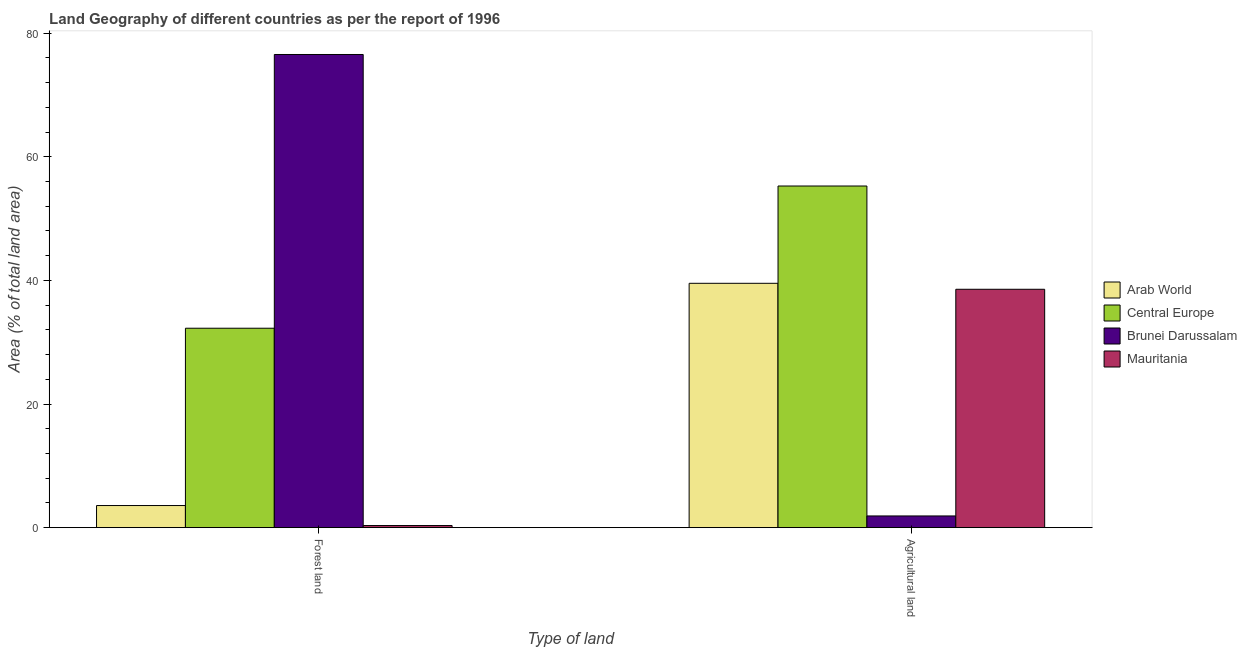How many different coloured bars are there?
Ensure brevity in your answer.  4. How many groups of bars are there?
Your answer should be very brief. 2. Are the number of bars on each tick of the X-axis equal?
Your answer should be compact. Yes. What is the label of the 2nd group of bars from the left?
Provide a short and direct response. Agricultural land. What is the percentage of land area under forests in Brunei Darussalam?
Make the answer very short. 76.55. Across all countries, what is the maximum percentage of land area under forests?
Provide a short and direct response. 76.55. Across all countries, what is the minimum percentage of land area under forests?
Ensure brevity in your answer.  0.35. In which country was the percentage of land area under forests maximum?
Ensure brevity in your answer.  Brunei Darussalam. In which country was the percentage of land area under forests minimum?
Offer a very short reply. Mauritania. What is the total percentage of land area under agriculture in the graph?
Offer a very short reply. 135.27. What is the difference between the percentage of land area under agriculture in Brunei Darussalam and that in Mauritania?
Make the answer very short. -36.67. What is the difference between the percentage of land area under forests in Arab World and the percentage of land area under agriculture in Mauritania?
Keep it short and to the point. -34.98. What is the average percentage of land area under forests per country?
Provide a succinct answer. 28.19. What is the difference between the percentage of land area under agriculture and percentage of land area under forests in Mauritania?
Your answer should be very brief. 38.22. In how many countries, is the percentage of land area under agriculture greater than 24 %?
Provide a succinct answer. 3. What is the ratio of the percentage of land area under agriculture in Central Europe to that in Brunei Darussalam?
Your answer should be very brief. 29.13. Is the percentage of land area under agriculture in Arab World less than that in Central Europe?
Your answer should be compact. Yes. What does the 3rd bar from the left in Agricultural land represents?
Make the answer very short. Brunei Darussalam. What does the 3rd bar from the right in Forest land represents?
Offer a very short reply. Central Europe. What is the difference between two consecutive major ticks on the Y-axis?
Provide a short and direct response. 20. Are the values on the major ticks of Y-axis written in scientific E-notation?
Your answer should be very brief. No. What is the title of the graph?
Give a very brief answer. Land Geography of different countries as per the report of 1996. What is the label or title of the X-axis?
Make the answer very short. Type of land. What is the label or title of the Y-axis?
Make the answer very short. Area (% of total land area). What is the Area (% of total land area) in Arab World in Forest land?
Offer a very short reply. 3.58. What is the Area (% of total land area) of Central Europe in Forest land?
Ensure brevity in your answer.  32.27. What is the Area (% of total land area) in Brunei Darussalam in Forest land?
Your answer should be compact. 76.55. What is the Area (% of total land area) of Mauritania in Forest land?
Your answer should be compact. 0.35. What is the Area (% of total land area) in Arab World in Agricultural land?
Provide a succinct answer. 39.53. What is the Area (% of total land area) in Central Europe in Agricultural land?
Give a very brief answer. 55.27. What is the Area (% of total land area) of Brunei Darussalam in Agricultural land?
Offer a very short reply. 1.9. What is the Area (% of total land area) in Mauritania in Agricultural land?
Your answer should be compact. 38.57. Across all Type of land, what is the maximum Area (% of total land area) in Arab World?
Offer a very short reply. 39.53. Across all Type of land, what is the maximum Area (% of total land area) in Central Europe?
Keep it short and to the point. 55.27. Across all Type of land, what is the maximum Area (% of total land area) of Brunei Darussalam?
Offer a very short reply. 76.55. Across all Type of land, what is the maximum Area (% of total land area) of Mauritania?
Offer a very short reply. 38.57. Across all Type of land, what is the minimum Area (% of total land area) of Arab World?
Your answer should be compact. 3.58. Across all Type of land, what is the minimum Area (% of total land area) of Central Europe?
Keep it short and to the point. 32.27. Across all Type of land, what is the minimum Area (% of total land area) in Brunei Darussalam?
Give a very brief answer. 1.9. Across all Type of land, what is the minimum Area (% of total land area) in Mauritania?
Keep it short and to the point. 0.35. What is the total Area (% of total land area) in Arab World in the graph?
Give a very brief answer. 43.11. What is the total Area (% of total land area) in Central Europe in the graph?
Offer a very short reply. 87.54. What is the total Area (% of total land area) of Brunei Darussalam in the graph?
Your response must be concise. 78.44. What is the total Area (% of total land area) of Mauritania in the graph?
Your answer should be compact. 38.91. What is the difference between the Area (% of total land area) in Arab World in Forest land and that in Agricultural land?
Offer a terse response. -35.95. What is the difference between the Area (% of total land area) in Central Europe in Forest land and that in Agricultural land?
Provide a succinct answer. -23.01. What is the difference between the Area (% of total land area) in Brunei Darussalam in Forest land and that in Agricultural land?
Your answer should be very brief. 74.65. What is the difference between the Area (% of total land area) in Mauritania in Forest land and that in Agricultural land?
Ensure brevity in your answer.  -38.22. What is the difference between the Area (% of total land area) of Arab World in Forest land and the Area (% of total land area) of Central Europe in Agricultural land?
Give a very brief answer. -51.69. What is the difference between the Area (% of total land area) in Arab World in Forest land and the Area (% of total land area) in Brunei Darussalam in Agricultural land?
Provide a short and direct response. 1.68. What is the difference between the Area (% of total land area) in Arab World in Forest land and the Area (% of total land area) in Mauritania in Agricultural land?
Give a very brief answer. -34.98. What is the difference between the Area (% of total land area) in Central Europe in Forest land and the Area (% of total land area) in Brunei Darussalam in Agricultural land?
Make the answer very short. 30.37. What is the difference between the Area (% of total land area) of Central Europe in Forest land and the Area (% of total land area) of Mauritania in Agricultural land?
Provide a short and direct response. -6.3. What is the difference between the Area (% of total land area) of Brunei Darussalam in Forest land and the Area (% of total land area) of Mauritania in Agricultural land?
Your answer should be compact. 37.98. What is the average Area (% of total land area) in Arab World per Type of land?
Your response must be concise. 21.56. What is the average Area (% of total land area) in Central Europe per Type of land?
Give a very brief answer. 43.77. What is the average Area (% of total land area) in Brunei Darussalam per Type of land?
Provide a succinct answer. 39.22. What is the average Area (% of total land area) in Mauritania per Type of land?
Make the answer very short. 19.46. What is the difference between the Area (% of total land area) in Arab World and Area (% of total land area) in Central Europe in Forest land?
Offer a very short reply. -28.68. What is the difference between the Area (% of total land area) in Arab World and Area (% of total land area) in Brunei Darussalam in Forest land?
Your answer should be very brief. -72.96. What is the difference between the Area (% of total land area) in Arab World and Area (% of total land area) in Mauritania in Forest land?
Provide a short and direct response. 3.24. What is the difference between the Area (% of total land area) of Central Europe and Area (% of total land area) of Brunei Darussalam in Forest land?
Provide a succinct answer. -44.28. What is the difference between the Area (% of total land area) of Central Europe and Area (% of total land area) of Mauritania in Forest land?
Offer a very short reply. 31.92. What is the difference between the Area (% of total land area) in Brunei Darussalam and Area (% of total land area) in Mauritania in Forest land?
Provide a short and direct response. 76.2. What is the difference between the Area (% of total land area) in Arab World and Area (% of total land area) in Central Europe in Agricultural land?
Keep it short and to the point. -15.74. What is the difference between the Area (% of total land area) in Arab World and Area (% of total land area) in Brunei Darussalam in Agricultural land?
Keep it short and to the point. 37.63. What is the difference between the Area (% of total land area) of Arab World and Area (% of total land area) of Mauritania in Agricultural land?
Your answer should be compact. 0.97. What is the difference between the Area (% of total land area) of Central Europe and Area (% of total land area) of Brunei Darussalam in Agricultural land?
Your answer should be compact. 53.37. What is the difference between the Area (% of total land area) of Central Europe and Area (% of total land area) of Mauritania in Agricultural land?
Offer a terse response. 16.71. What is the difference between the Area (% of total land area) of Brunei Darussalam and Area (% of total land area) of Mauritania in Agricultural land?
Offer a terse response. -36.67. What is the ratio of the Area (% of total land area) of Arab World in Forest land to that in Agricultural land?
Offer a terse response. 0.09. What is the ratio of the Area (% of total land area) of Central Europe in Forest land to that in Agricultural land?
Offer a very short reply. 0.58. What is the ratio of the Area (% of total land area) of Brunei Darussalam in Forest land to that in Agricultural land?
Offer a very short reply. 40.34. What is the ratio of the Area (% of total land area) in Mauritania in Forest land to that in Agricultural land?
Offer a very short reply. 0.01. What is the difference between the highest and the second highest Area (% of total land area) of Arab World?
Your answer should be compact. 35.95. What is the difference between the highest and the second highest Area (% of total land area) in Central Europe?
Ensure brevity in your answer.  23.01. What is the difference between the highest and the second highest Area (% of total land area) of Brunei Darussalam?
Your response must be concise. 74.65. What is the difference between the highest and the second highest Area (% of total land area) in Mauritania?
Make the answer very short. 38.22. What is the difference between the highest and the lowest Area (% of total land area) of Arab World?
Keep it short and to the point. 35.95. What is the difference between the highest and the lowest Area (% of total land area) in Central Europe?
Ensure brevity in your answer.  23.01. What is the difference between the highest and the lowest Area (% of total land area) of Brunei Darussalam?
Make the answer very short. 74.65. What is the difference between the highest and the lowest Area (% of total land area) of Mauritania?
Ensure brevity in your answer.  38.22. 